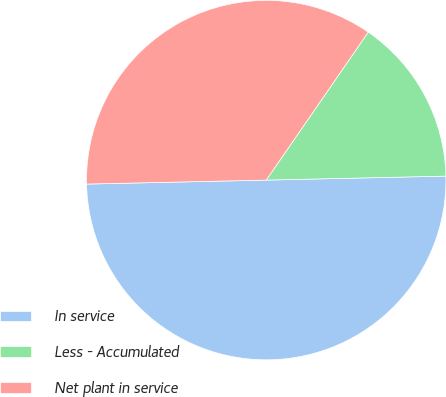Convert chart to OTSL. <chart><loc_0><loc_0><loc_500><loc_500><pie_chart><fcel>In service<fcel>Less - Accumulated<fcel>Net plant in service<nl><fcel>50.0%<fcel>15.04%<fcel>34.96%<nl></chart> 